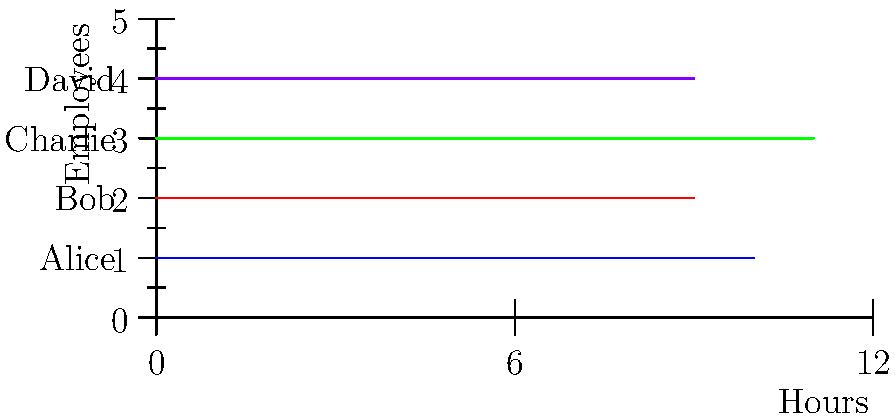As a small business owner, you need to calculate overtime pay for your employees based on the time clock chart above. Regular hours are paid at $15 per hour, and overtime (hours worked beyond 8 hours) is paid at 1.5 times the regular rate. What is the total amount you need to pay for overtime across all employees for this day? Let's calculate the overtime for each employee:

1. Alice:
   - Worked 10 hours
   - Overtime: 10 - 8 = 2 hours

2. Bob:
   - Worked 9 hours
   - Overtime: 9 - 8 = 1 hour

3. Charlie:
   - Worked 11 hours
   - Overtime: 11 - 8 = 3 hours

4. David:
   - Worked 9 hours
   - Overtime: 9 - 8 = 1 hour

Total overtime hours: 2 + 1 + 3 + 1 = 7 hours

Overtime rate: $15 × 1.5 = $22.50 per hour

Total overtime pay: 7 hours × $22.50/hour = $157.50
Answer: $157.50 